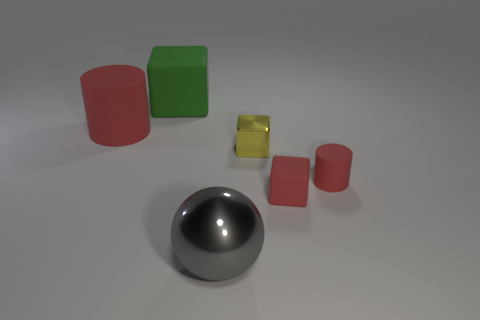The yellow metal block is what size?
Offer a very short reply. Small. Is the big object on the right side of the big cube made of the same material as the green thing?
Make the answer very short. No. The metallic thing that is the same shape as the green matte object is what color?
Your answer should be very brief. Yellow. Is the color of the large cylinder that is on the left side of the big gray shiny object the same as the metallic sphere?
Your answer should be very brief. No. There is a red cube; are there any small things to the right of it?
Provide a succinct answer. Yes. There is a cube that is behind the red block and in front of the green matte thing; what is its color?
Give a very brief answer. Yellow. What is the shape of the big object that is the same color as the tiny rubber cylinder?
Your answer should be compact. Cylinder. There is a red matte cylinder on the left side of the red cylinder that is in front of the tiny yellow cube; what is its size?
Your answer should be very brief. Large. How many blocks are green rubber things or yellow shiny things?
Make the answer very short. 2. There is a matte cylinder that is the same size as the yellow block; what is its color?
Ensure brevity in your answer.  Red. 